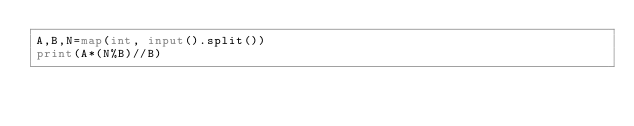Convert code to text. <code><loc_0><loc_0><loc_500><loc_500><_Python_>A,B,N=map(int, input().split())
print(A*(N%B)//B)</code> 